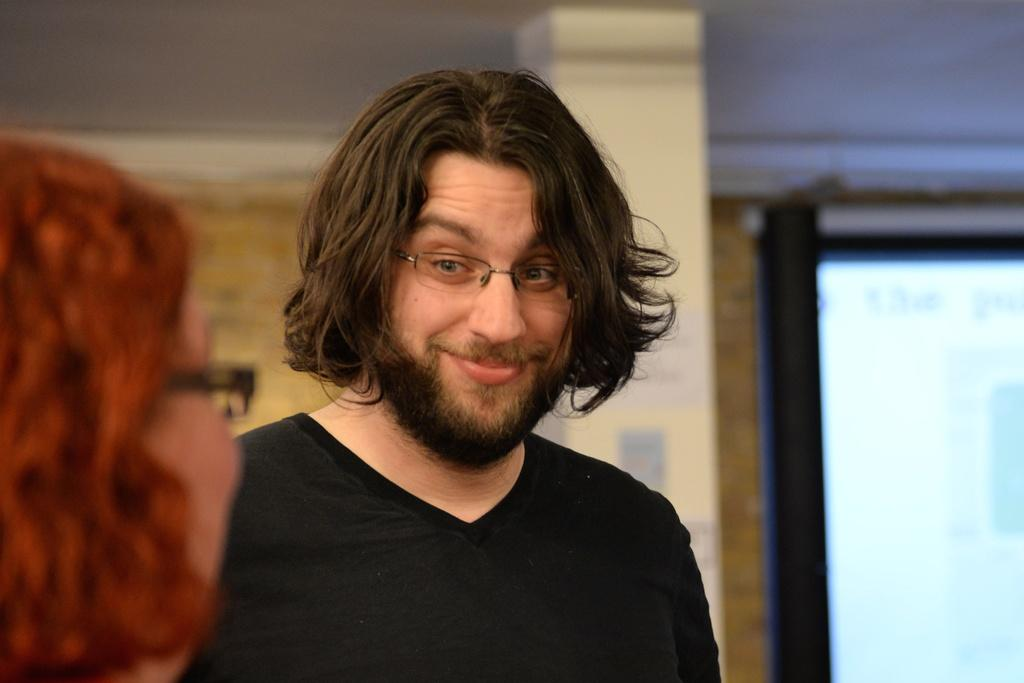What is the man in the image doing? The man is standing and smiling in the image. Who else is present in the image? There is a woman in the image. What can be seen in the background of the image? There is a pillar, a screen with text, and a wall in the background of the image. What type of game is the man playing with the skate in the image? There is no game or skate present in the image. What does the mom in the image say to the man? There is no mention of a mom or any dialogue in the image. 